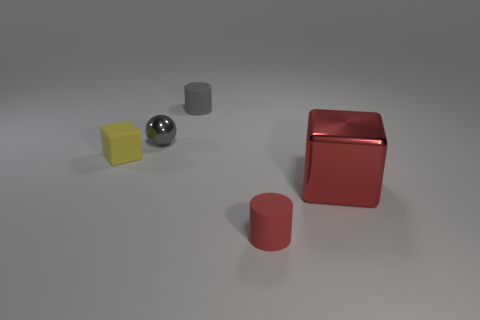Is the number of yellow matte things greater than the number of small cyan matte cylinders?
Give a very brief answer. Yes. What is the color of the tiny object in front of the red thing on the right side of the red object that is in front of the big block?
Offer a very short reply. Red. There is a matte cylinder that is behind the large block; does it have the same color as the tiny cylinder that is to the right of the small gray matte object?
Your answer should be compact. No. What number of large red shiny objects are to the left of the yellow matte cube in front of the tiny gray cylinder?
Give a very brief answer. 0. Are any rubber cylinders visible?
Offer a terse response. Yes. How many other objects are there of the same color as the small sphere?
Keep it short and to the point. 1. Are there fewer big red shiny cubes than big brown matte things?
Give a very brief answer. No. What shape is the metal thing to the left of the matte cylinder in front of the yellow rubber object?
Ensure brevity in your answer.  Sphere. Are there any small metallic balls on the right side of the tiny gray cylinder?
Keep it short and to the point. No. What color is the other rubber cylinder that is the same size as the red matte cylinder?
Ensure brevity in your answer.  Gray. 